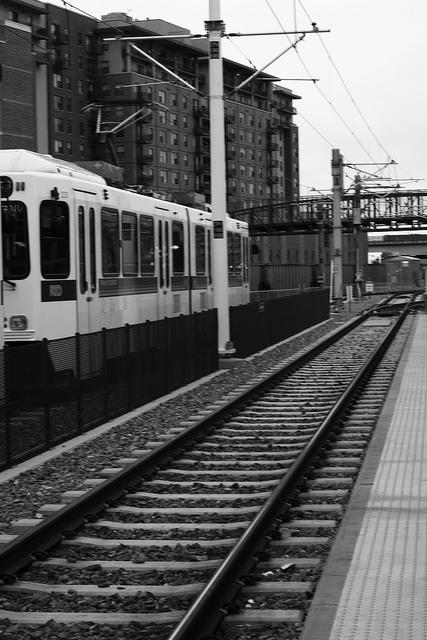What color scheme is the photo in?
Keep it brief. Black and white. Is the picture in color?
Be succinct. No. Is this a commuter train?
Short answer required. Yes. What colors are the train?
Be succinct. White. 